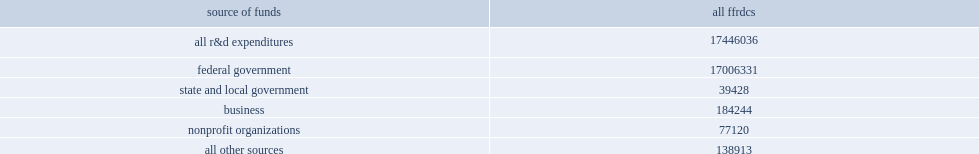Would you mind parsing the complete table? {'header': ['source of funds', 'all ffrdcs'], 'rows': [['all r&d expenditures', '17446036'], ['federal government', '17006331'], ['state and local government', '39428'], ['business', '184244'], ['nonprofit organizations', '77120'], ['all other sources', '138913']]} How many thousand dollars did federal funding account of the ffrdc's total expenditures in fy 2012? 17006331.0. In fy 2012, how many thousand dollars did ffrdcs report in r&d expenditures funded by businesses? 184244.0. In fy 2012, how many thousand dollars did ffrdcs report in r&d expenditures funded by nonprofit organizations? 77120.0. In fy 2012, how many thousand dollars did ffrdcs report in r&d expenditures funded by state and local governments? 39428.0. In fy 2012, how many thousand dollars did ffrdcs report in r&d expenditures funded by all other nonfederal sources? 138913.0. 